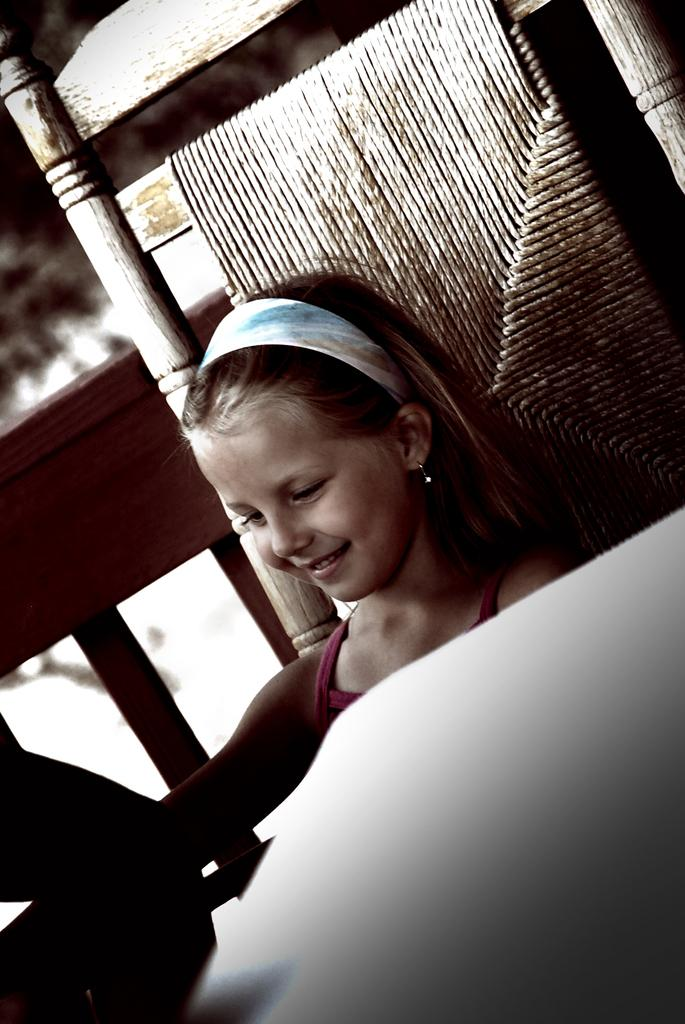Who is the main subject in the image? There is a girl in the image. What is the girl doing in the image? The girl is seated. What is the girl's facial expression in the image? The girl is smiling. What type of cream is the girl using to answer questions in the image? There is no cream or answering of questions present in the image; it simply shows a girl who is seated and smiling. 